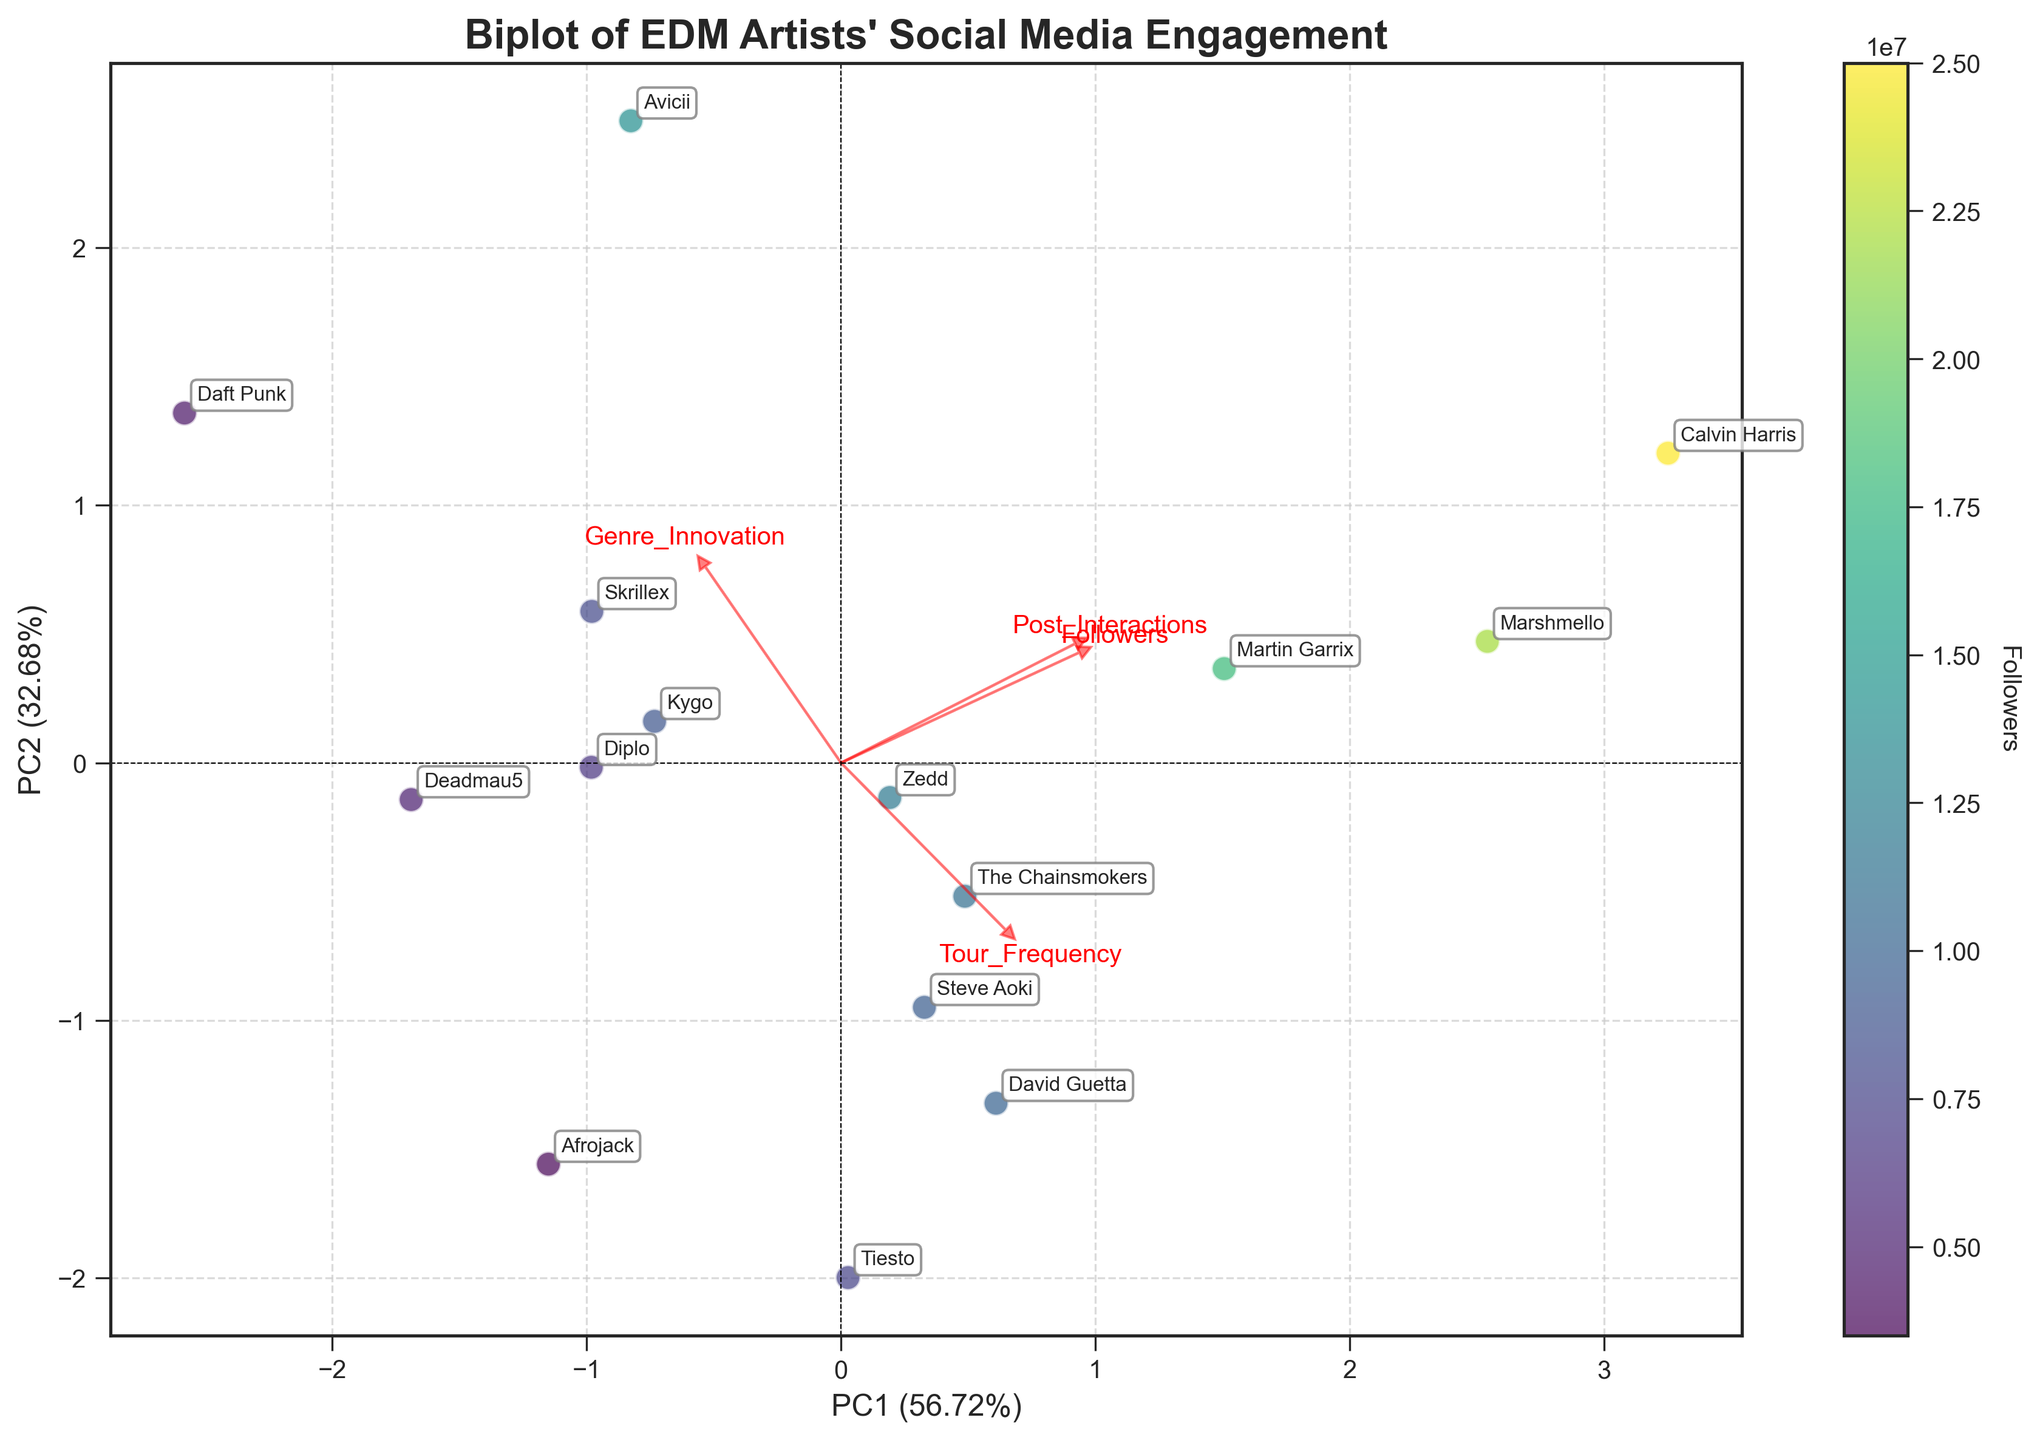What's the title of the figure? The title of the figure is located at the top center of the plot. It reads "Biplot of EDM Artists' Social Media Engagement".
Answer: Biplot of EDM Artists' Social Media Engagement Which artist has the highest number of followers? By examining the color intensity on the scatter plot, the artist with the most followers will be the one with the darkest color. The annotations indicate this is Calvin Harris.
Answer: Calvin Harris Is there a clear correlation between 'Followers' and interactions on posts? Look at the scatter distribution and the color gradient. The artists with high post interactions (upper scatter points) also show darker colors, implying a higher number of followers. This indicates a positive correlation.
Answer: Yes Which two artists are the closest to each other in the PCA plot? Examine the proximity of the scatter points. The closest artists based on the PCA transformed data appear to be Zedd and The Chainsmokers.
Answer: Zedd and The Chainsmokers What does PC1 primarily represent? The loading vectors indicate the importance of each feature in PC1. The feature arrows pointing most along PC1 suggest it's influenced by 'Followers' and 'Post_Interactions'.
Answer: Followers and Post_Interactions Which artist appears to have the lowest 'Tour Frequency'? By observing the scatter point associated with the annotative label on the plot, Daft Punk has the lowest 'Tour Frequency' with a visually notable large arrow deviation.
Answer: Daft Punk Which feature seems to contribute most significantly to PC2's variance explanation? By looking at the orientation of the loading vectors, 'Tour_Frequency' and 'Genre_Innovation' arrows are most aligned along PC2, indicating their strong influence.
Answer: Genre_Innovation and Tour_Frequency Compare Calvin Harris and Daft Punk. Which one is more innovative in genre according to the biplot? By referring to the projection of both artists onto the 'Genre_Innovation' vector, Daft Punk's position shows a higher score than Calvin Harris.
Answer: Daft Punk Among the artists, who has the smallest social media interaction yet still tours frequently? By identifying the point with a low 'Post_Interactions' score but with a higher 'Tour_Frequency' projection, Steve Aoki appears satisfying these conditions.
Answer: Steve Aoki How much of the total variance is explained by the first principal component (PC1)? The variance explained by each principal component is displayed on the axis labels. PC1 explains 54.32% of the total variance.
Answer: 54.32% 